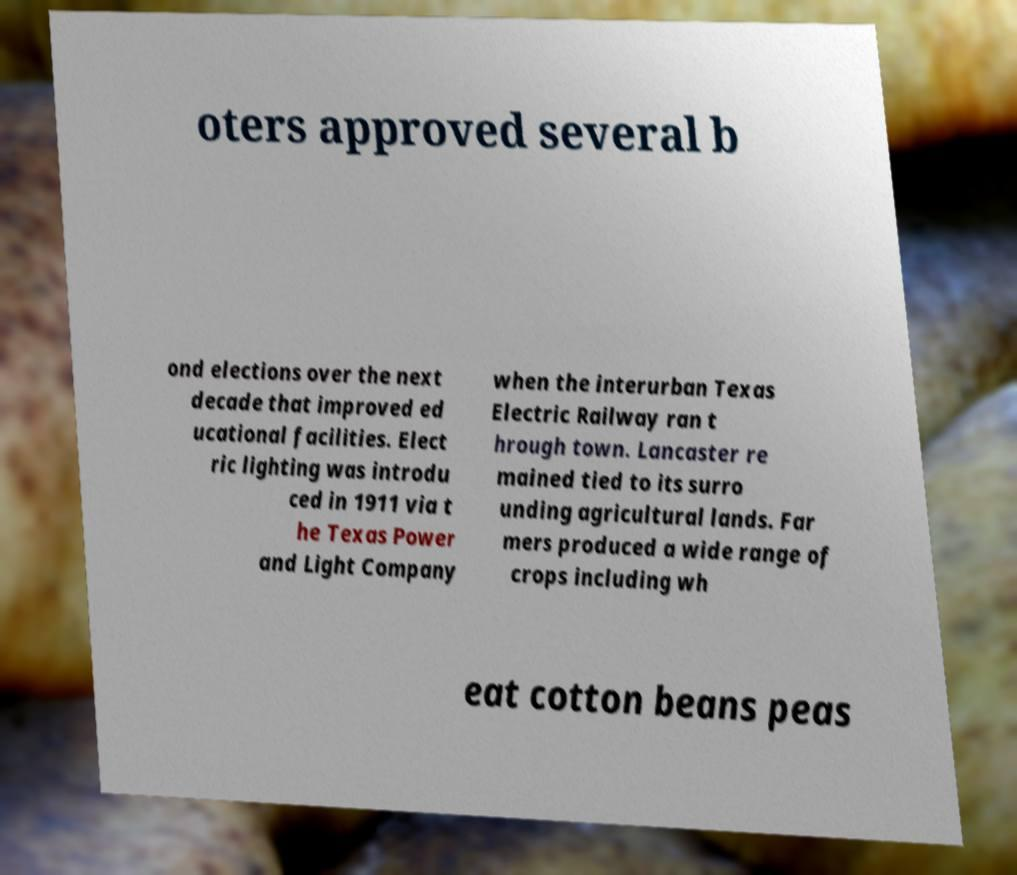Please read and relay the text visible in this image. What does it say? oters approved several b ond elections over the next decade that improved ed ucational facilities. Elect ric lighting was introdu ced in 1911 via t he Texas Power and Light Company when the interurban Texas Electric Railway ran t hrough town. Lancaster re mained tied to its surro unding agricultural lands. Far mers produced a wide range of crops including wh eat cotton beans peas 